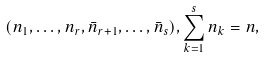Convert formula to latex. <formula><loc_0><loc_0><loc_500><loc_500>( n _ { 1 } , \dots , n _ { r } , \bar { n } _ { r + 1 } , \dots , \bar { n } _ { s } ) , \sum _ { k = 1 } ^ { s } n _ { k } = n ,</formula> 